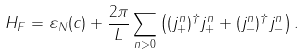Convert formula to latex. <formula><loc_0><loc_0><loc_500><loc_500>H _ { F } = { \varepsilon } _ { N } ( c ) + \frac { 2 \pi } { L } \sum _ { n > 0 } \left ( ( j _ { + } ^ { n } ) ^ { \dagger } j _ { + } ^ { n } + ( j _ { - } ^ { n } ) ^ { \dagger } j _ { - } ^ { n } \right ) .</formula> 